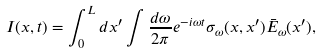Convert formula to latex. <formula><loc_0><loc_0><loc_500><loc_500>I ( x , t ) = \int ^ { L } _ { 0 } d x ^ { \prime } \int \frac { d \omega } { 2 \pi } e ^ { - i \omega t } \sigma _ { \omega } ( x , x ^ { \prime } ) { \bar { E } } _ { \omega } ( x ^ { \prime } ) ,</formula> 